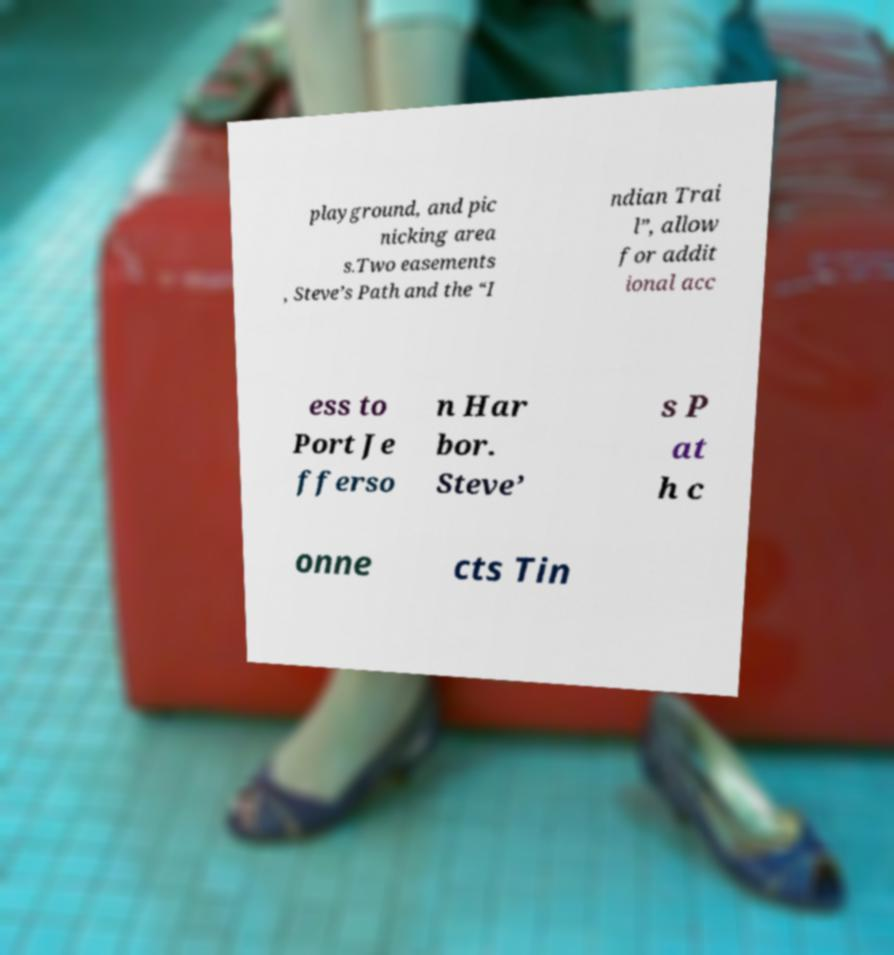There's text embedded in this image that I need extracted. Can you transcribe it verbatim? playground, and pic nicking area s.Two easements , Steve’s Path and the “I ndian Trai l”, allow for addit ional acc ess to Port Je fferso n Har bor. Steve’ s P at h c onne cts Tin 